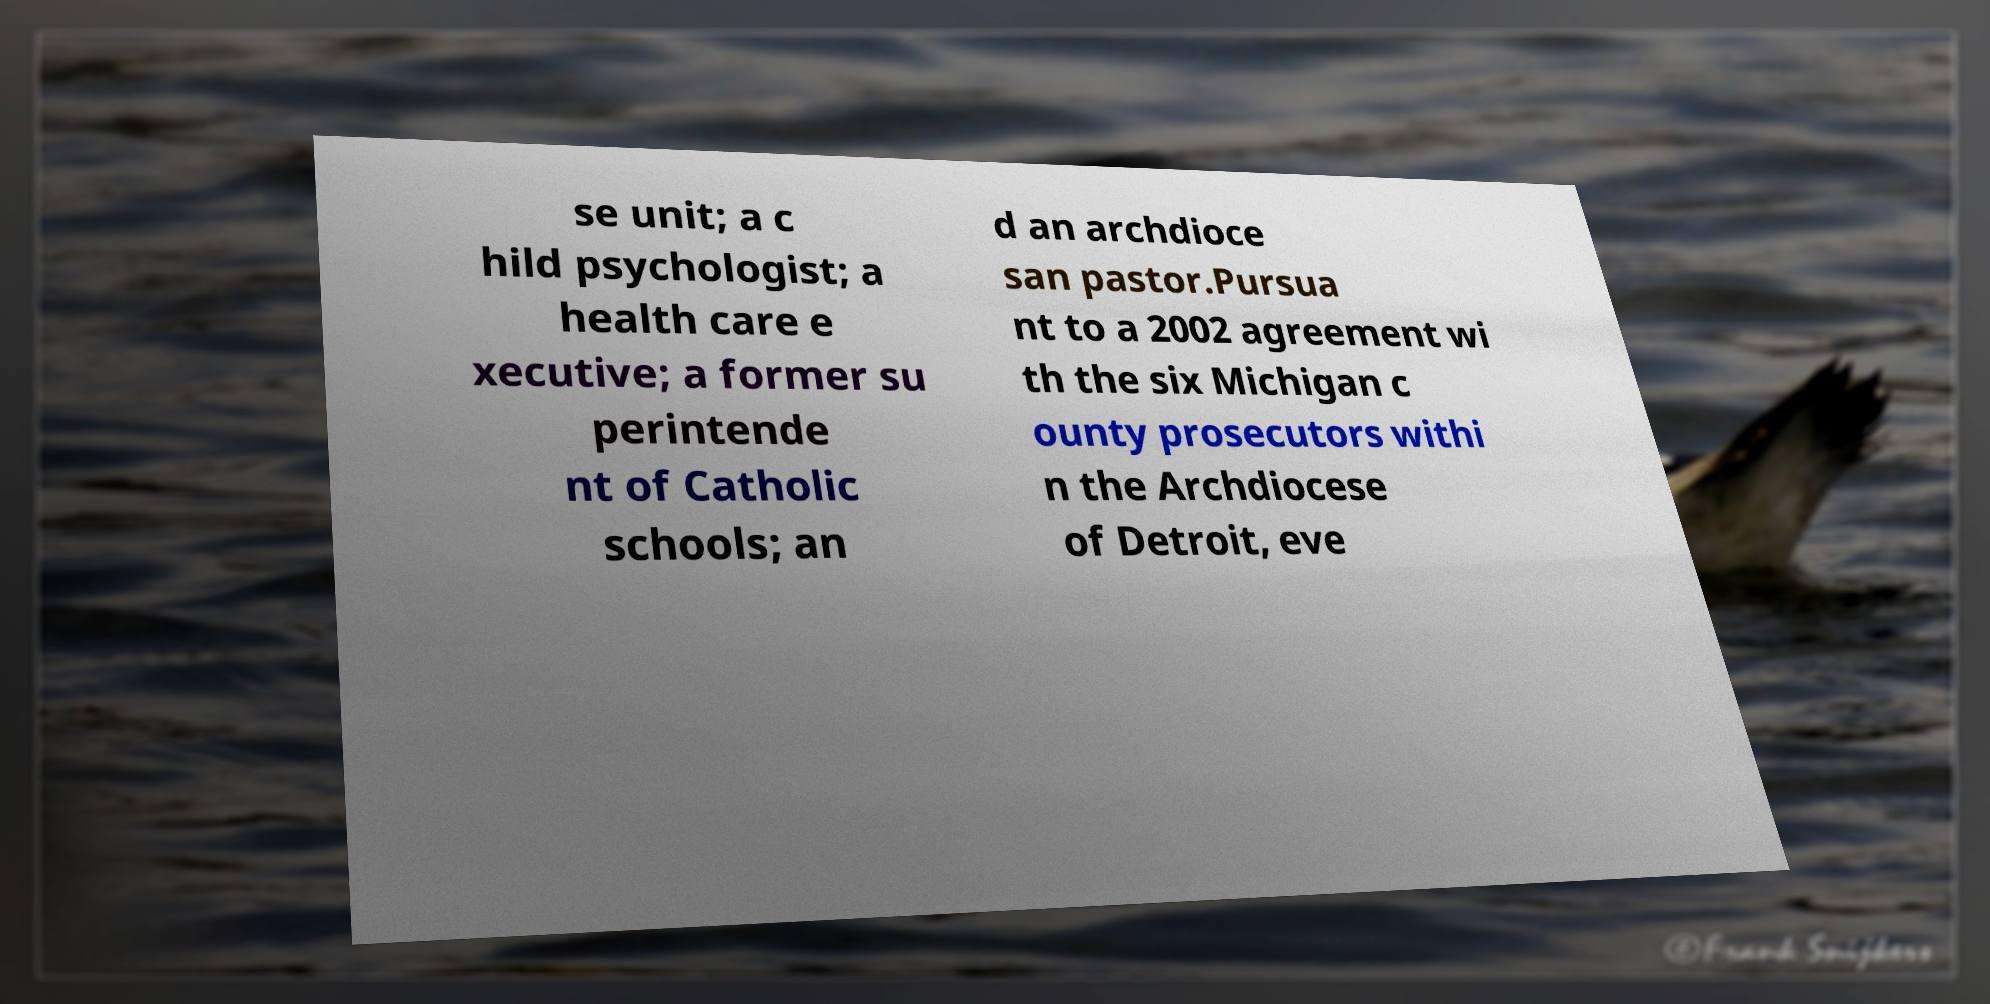Could you extract and type out the text from this image? se unit; a c hild psychologist; a health care e xecutive; a former su perintende nt of Catholic schools; an d an archdioce san pastor.Pursua nt to a 2002 agreement wi th the six Michigan c ounty prosecutors withi n the Archdiocese of Detroit, eve 